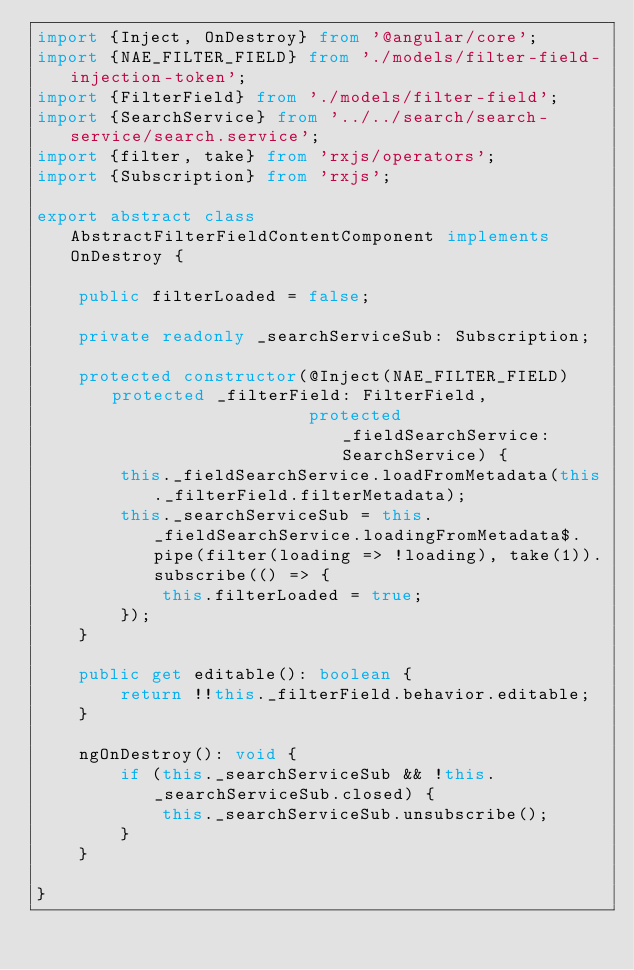<code> <loc_0><loc_0><loc_500><loc_500><_TypeScript_>import {Inject, OnDestroy} from '@angular/core';
import {NAE_FILTER_FIELD} from './models/filter-field-injection-token';
import {FilterField} from './models/filter-field';
import {SearchService} from '../../search/search-service/search.service';
import {filter, take} from 'rxjs/operators';
import {Subscription} from 'rxjs';

export abstract class AbstractFilterFieldContentComponent implements OnDestroy {

    public filterLoaded = false;

    private readonly _searchServiceSub: Subscription;

    protected constructor(@Inject(NAE_FILTER_FIELD) protected _filterField: FilterField,
                          protected _fieldSearchService: SearchService) {
        this._fieldSearchService.loadFromMetadata(this._filterField.filterMetadata);
        this._searchServiceSub = this._fieldSearchService.loadingFromMetadata$.pipe(filter(loading => !loading), take(1)).subscribe(() => {
            this.filterLoaded = true;
        });
    }

    public get editable(): boolean {
        return !!this._filterField.behavior.editable;
    }

    ngOnDestroy(): void {
        if (this._searchServiceSub && !this._searchServiceSub.closed) {
            this._searchServiceSub.unsubscribe();
        }
    }

}
</code> 